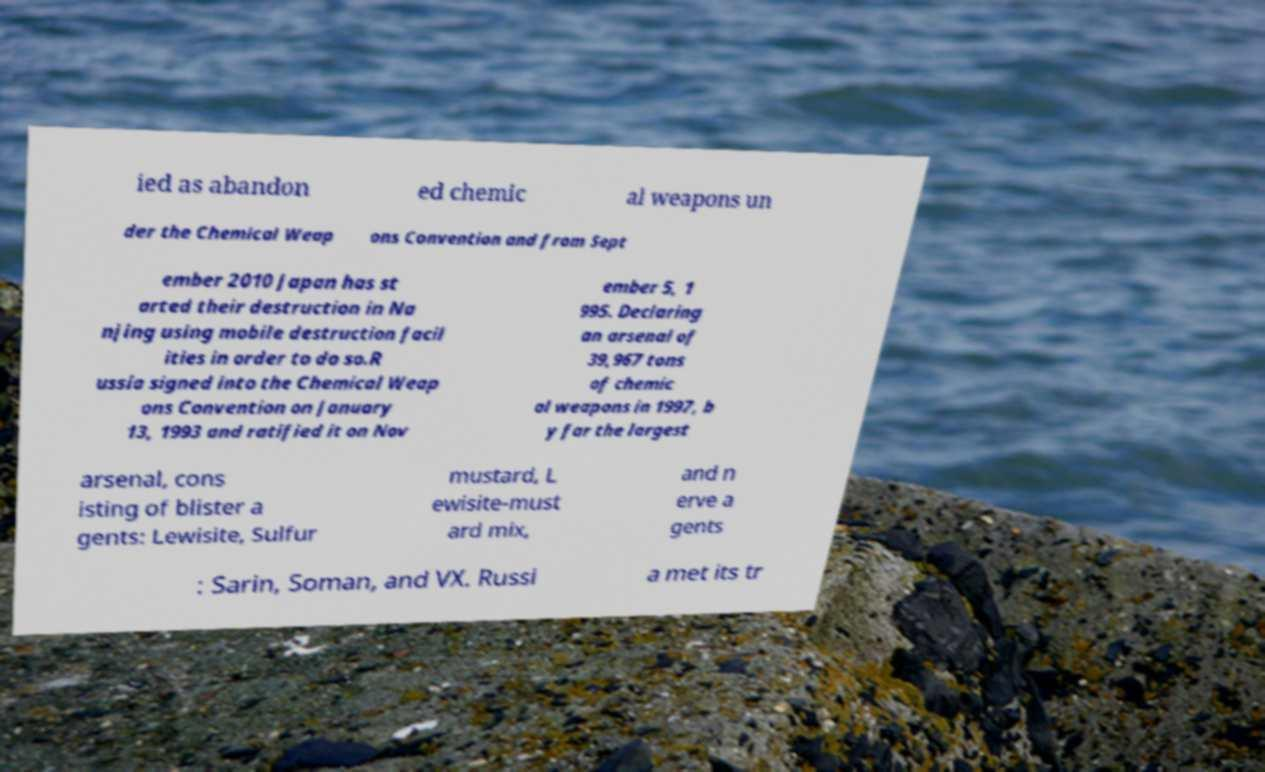I need the written content from this picture converted into text. Can you do that? ied as abandon ed chemic al weapons un der the Chemical Weap ons Convention and from Sept ember 2010 Japan has st arted their destruction in Na njing using mobile destruction facil ities in order to do so.R ussia signed into the Chemical Weap ons Convention on January 13, 1993 and ratified it on Nov ember 5, 1 995. Declaring an arsenal of 39,967 tons of chemic al weapons in 1997, b y far the largest arsenal, cons isting of blister a gents: Lewisite, Sulfur mustard, L ewisite-must ard mix, and n erve a gents : Sarin, Soman, and VX. Russi a met its tr 